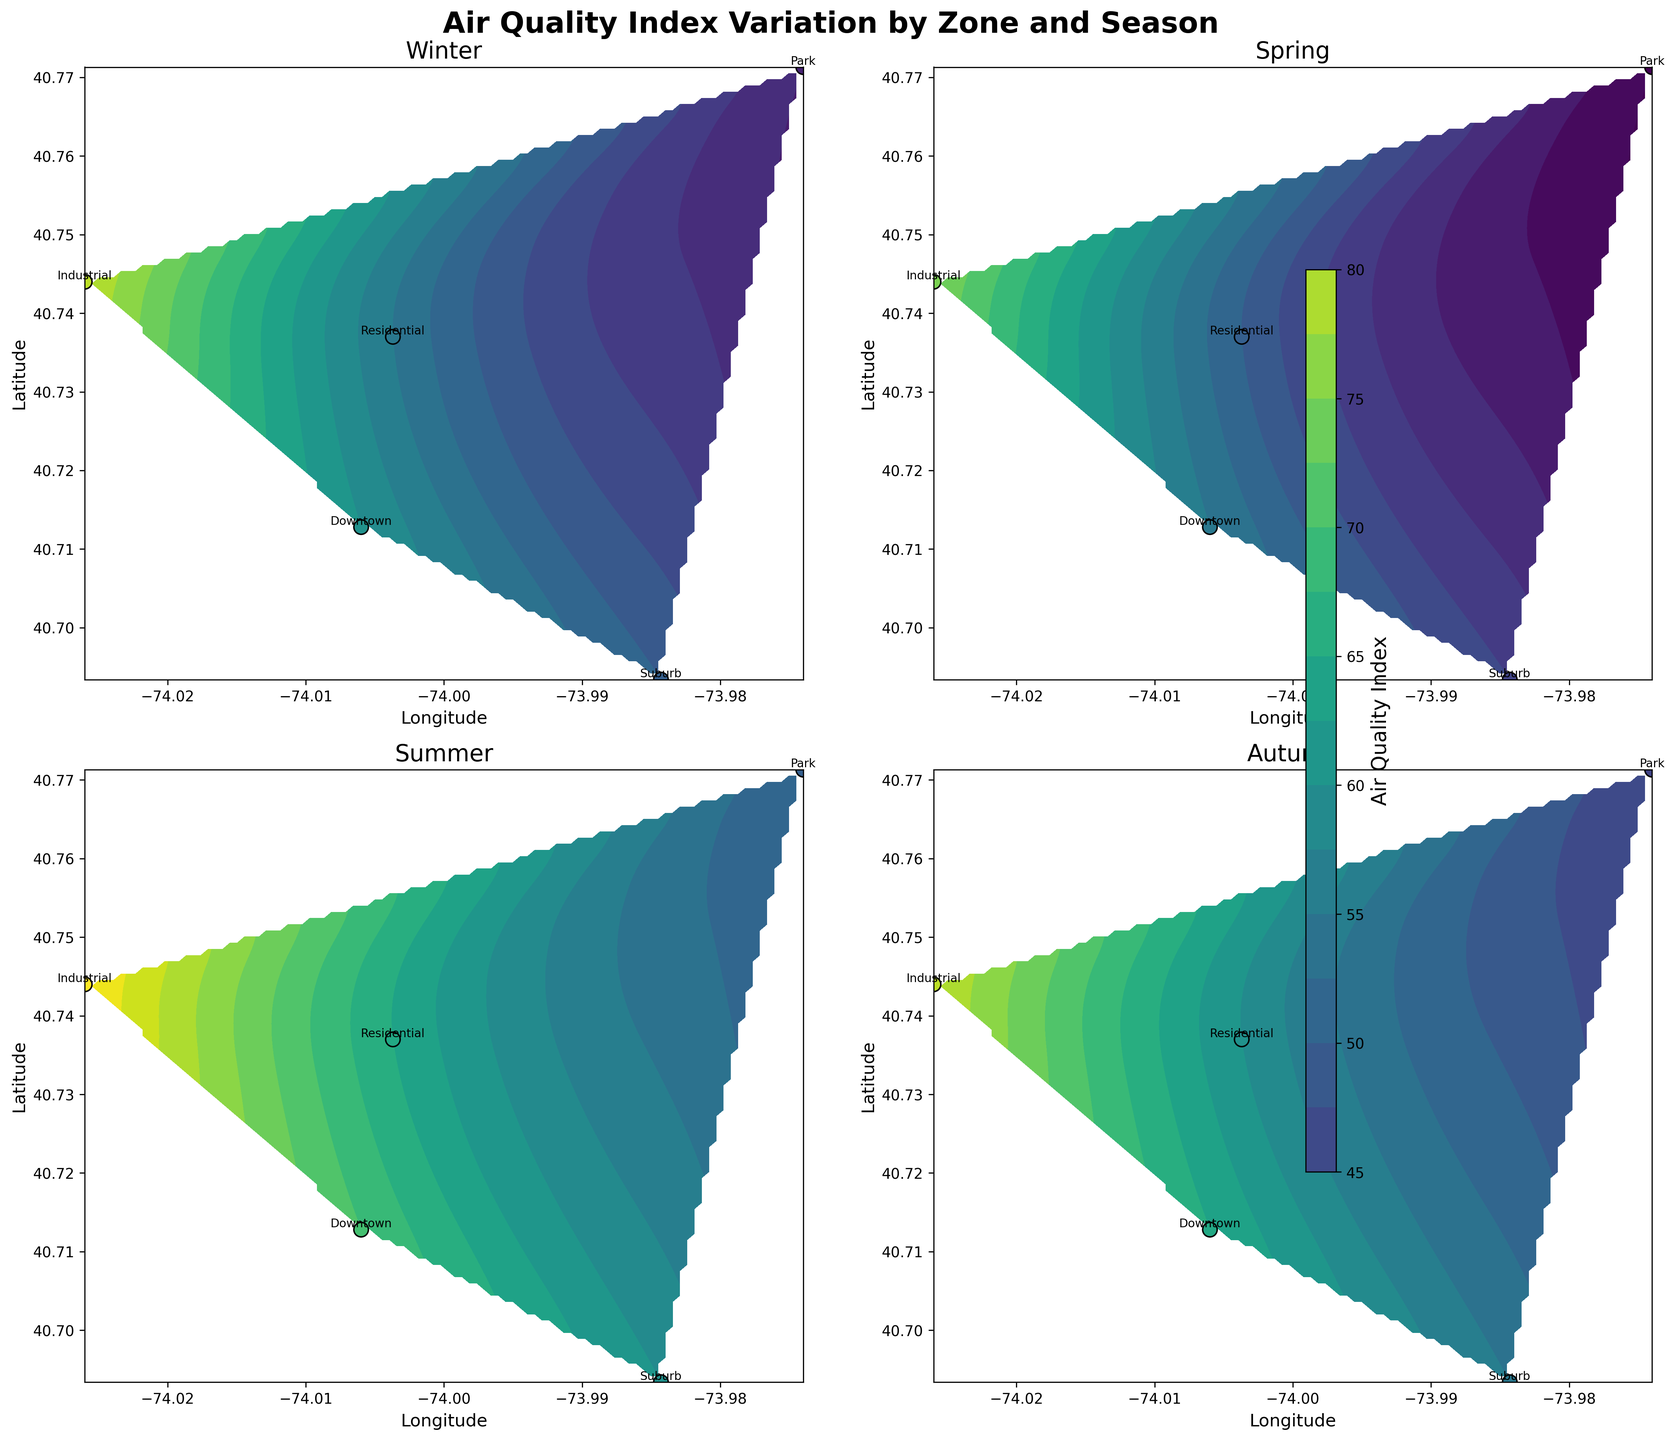what is the contour plot of AQI for the 'Winter' season depict? The contour plot for the 'Winter' season shows the variation in AQI across different zones based on their geographic coordinates (latitude and longitude). Contour lines and color gradients represent areas of similar AQI, with specific points indicating exact AQI levels in different zones. The map will likely show higher AQI in the Industrial zone and lower AQI in the Park and Suburb zones.
Answer: Variation of AQI across zones Which zone has the lowest AQI in the 'Summer' season? To identify the zone with the lowest AQI in 'Summer', we observe the plot for 'Summer' and look for the zone with the lightest color representing the lowest AQI value. Here, the Park zone with an AQI value of 50 is depicted with lighter color tones compared to other zones.
Answer: Park How does the AQI in the 'Downtown' zone change across seasons? Observing the plots for all four seasons, the AQI in the 'Downtown' zone changes as follows: Winter (60), Spring (55), Summer (70), and Autumn (65). This information is either annotated or can be estimated by color gradients. Calculations for each season are straightforward based on visual inspection.
Answer: Winter: 60, Spring: 55, Summer: 70, Autumn: 65 Which season has the highest AQI variation within a single zone, and which zone is it? The highest AQI variation within a single zone can be found by comparing the maximum and minimum AQI values across seasons for each zone. 'Industrial' zone varies from 75 in Spring to 85 in Summer, reflecting a maximum variation of 10 units, making it the zone with the highest seasonal variation in AQI.
Answer: Summer, Industrial zone What is the average AQI of the 'Residential' zone across all seasons? Summing up the AQI values for Residential across all seasons, we get (55 + 50 + 65 + 60). The average is calculated by dividing this sum by 4. Calculation steps: Total = 55 + 50 + 65 + 60 = 230, Average AQI = 230 / 4 = 57.5.
Answer: 57.5 Is AQI higher in 'Downtown' or 'Suburb' during 'Autumn'? Referring to the contour plots or annotations for Autumn, we compare the AQI values for Downtown which is 65 and Suburb which is 55. Therefore, AQI is higher in Downtown during Autumn.
Answer: Downtown Which zone has the consistently highest AQI throughout all seasons? Examining AQI values of zones across all seasons, 'Industrial' zone always has the highest AQI: Winter (80), Spring (75), Summer (85), Autumn (80). This trend indicates consistent high values across seasons.
Answer: Industrial Which season has the most even distribution of AQI across zones? Observing the contour plots for equal color distribution gradients within each zone, Spring shows the most even distribution of AQI values. The range from 35 (Park) to 75 (Industrial) is less variable compared to other seasons.
Answer: Spring What is the AQI difference between 'Park' and 'Industrial' zones in the 'Winter' season? Compare AQI values for Park (40) and Industrial (80) zones in Winter. Subtract the Park AQI from Industrial AQI. Calculation: 80 - 40 = 40 units, reflects discrepancy between zones.
Answer: 40 